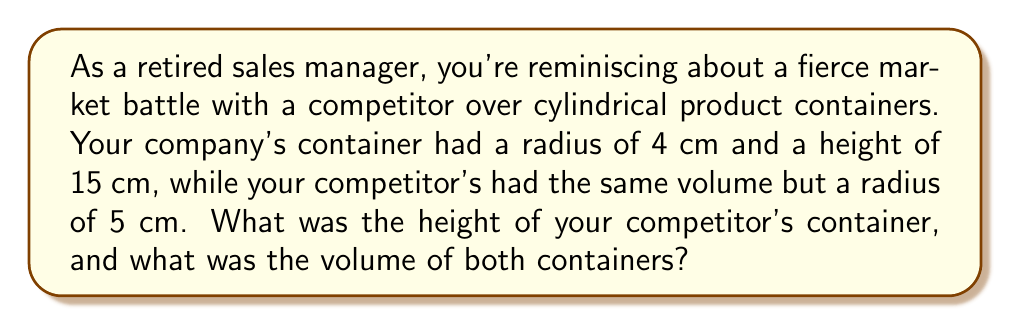Can you solve this math problem? Let's approach this step-by-step:

1) First, let's recall the formula for the volume of a cylinder:
   $$V = \pi r^2 h$$
   where $V$ is volume, $r$ is radius, and $h$ is height.

2) We know your company's container dimensions:
   Radius ($r_1$) = 4 cm
   Height ($h_1$) = 15 cm

3) Let's calculate the volume of your container:
   $$V_1 = \pi (4\text{ cm})^2 (15\text{ cm}) = 240\pi \text{ cm}^3$$

4) For the competitor's container, we know:
   Radius ($r_2$) = 5 cm
   Height ($h_2$) = unknown
   Volume ($V_2$) = $240\pi \text{ cm}^3$ (same as your container)

5) We can set up an equation:
   $$240\pi = \pi (5\text{ cm})^2 h_2$$

6) Simplify:
   $$240 = 25h_2$$

7) Solve for $h_2$:
   $$h_2 = \frac{240}{25} = 9.6\text{ cm}$$

Therefore, the competitor's container height was 9.6 cm, and both containers had a volume of $240\pi \text{ cm}^3$.

[asy]
import graph3;
size(200);
currentprojection=perspective(6,3,2);

// Your company's cylinder
draw(cylinder((0,0,0),4,15),blue+opacity(0.5));
label("Your container",(0,0,-2),S);

// Competitor's cylinder
draw(cylinder((10,0,0),5,9.6),red+opacity(0.5));
label("Competitor's container",(10,0,-2),S);
[/asy]
Answer: The competitor's container height was 9.6 cm, and both containers had a volume of $240\pi \text{ cm}^3 \approx 753.98 \text{ cm}^3$. 